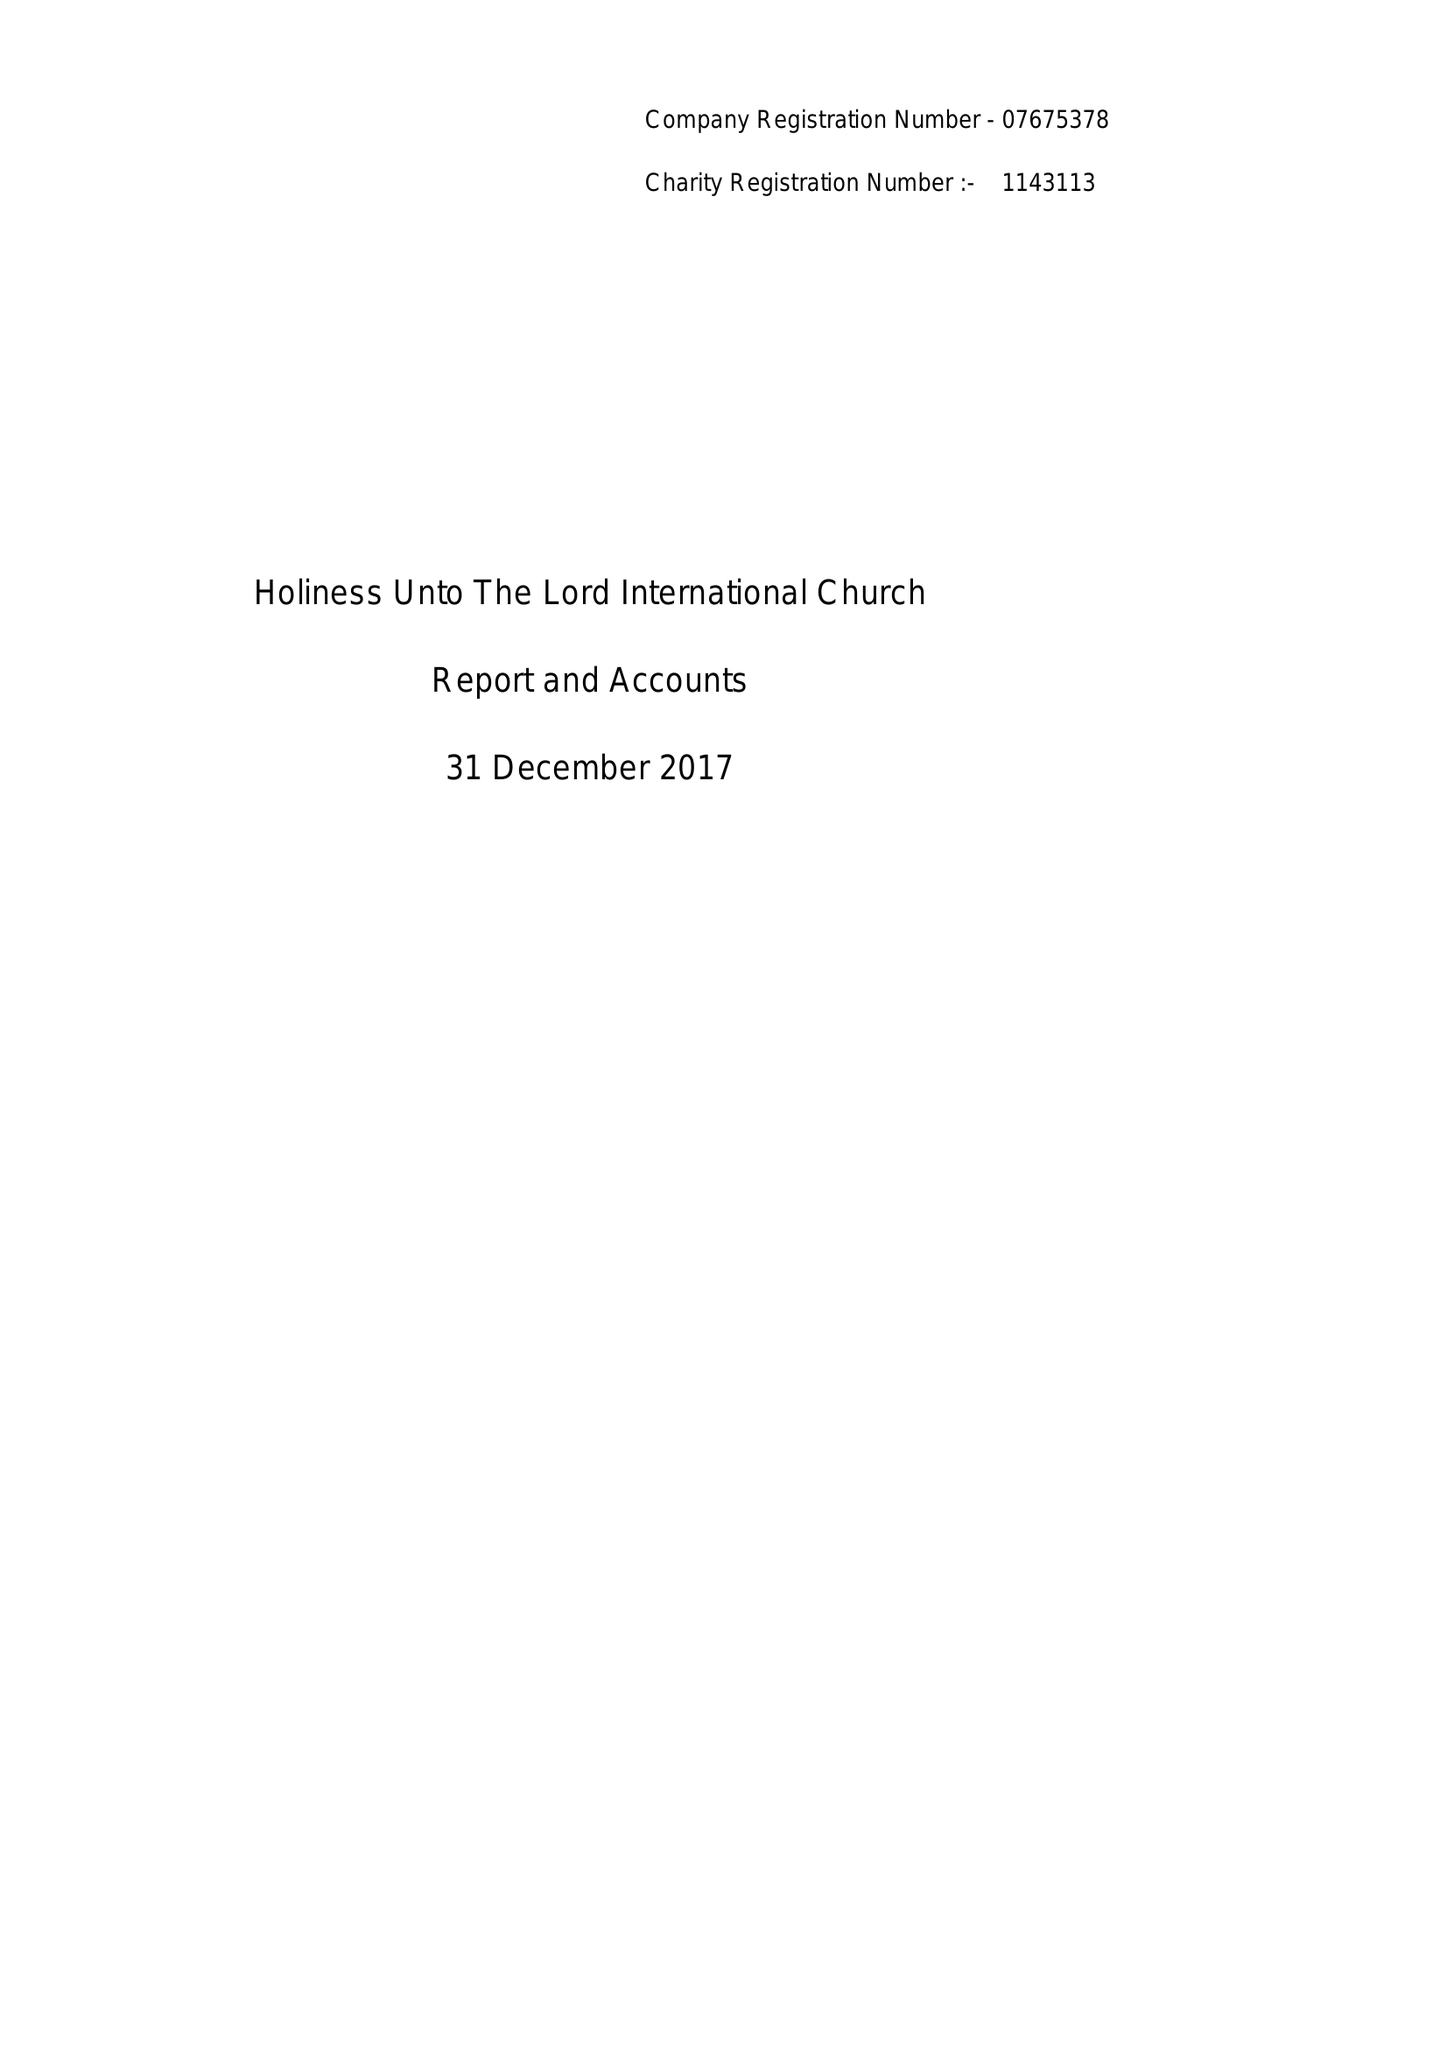What is the value for the charity_number?
Answer the question using a single word or phrase. 1143113 